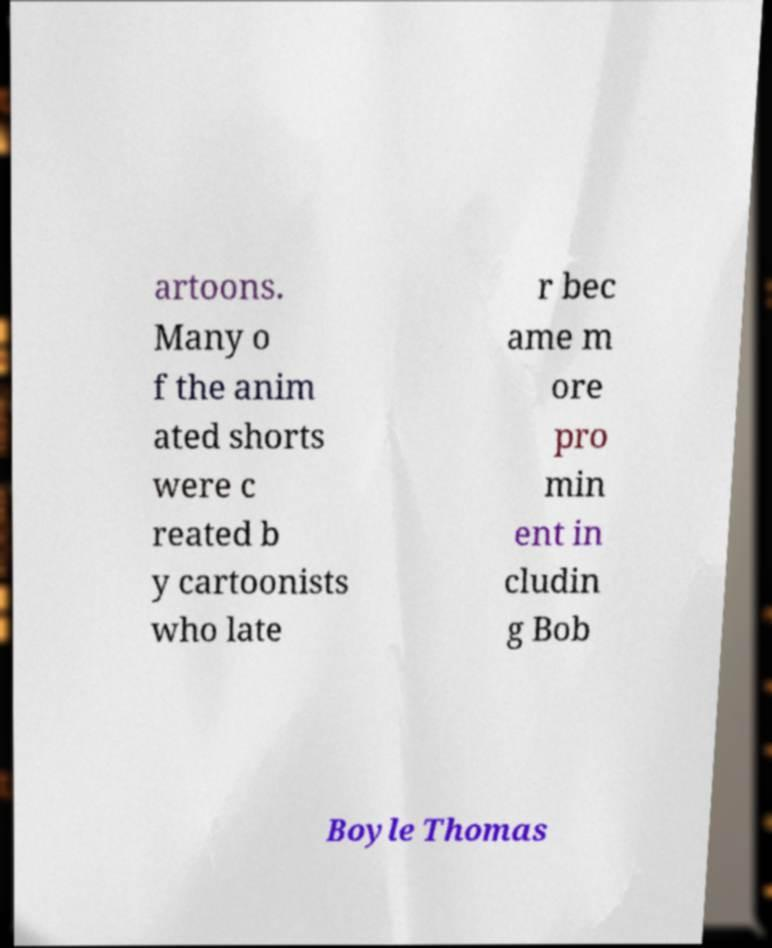Could you extract and type out the text from this image? artoons. Many o f the anim ated shorts were c reated b y cartoonists who late r bec ame m ore pro min ent in cludin g Bob Boyle Thomas 